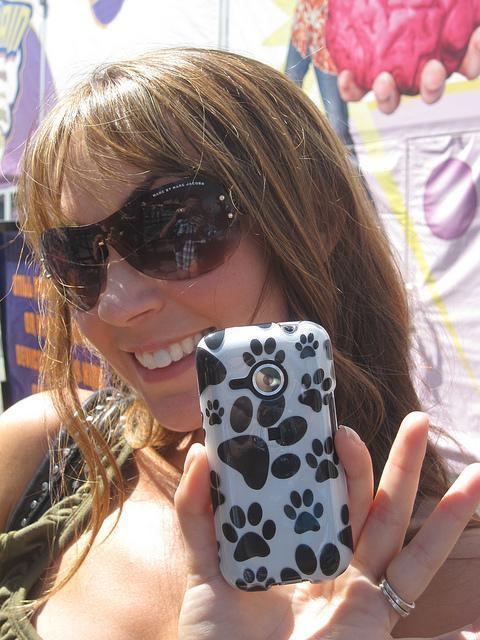How many trains are there?
Give a very brief answer. 0. 